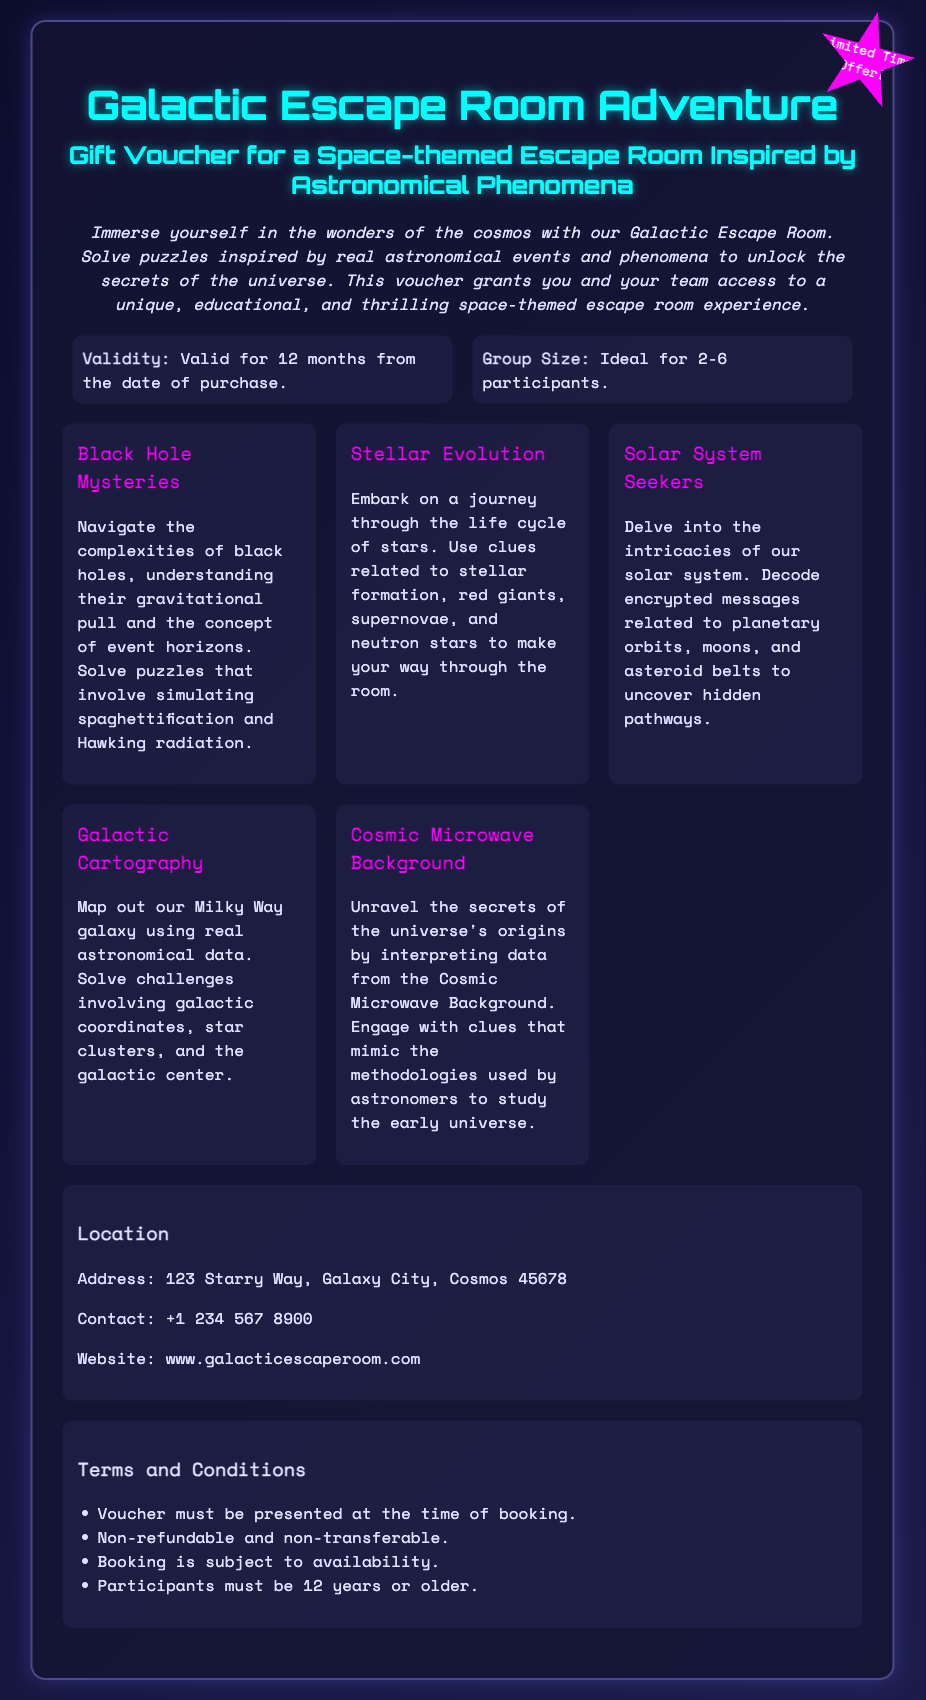What is the validity period of the voucher? The document states that the voucher is valid for 12 months from the date of purchase.
Answer: 12 months What is the ideal group size for the escape room? According to the document, the ideal group size is between 2 to 6 participants.
Answer: 2-6 participants What is one of the features highlighted in the escape room? The document lists multiple features, one of which is "Black Hole Mysteries."
Answer: Black Hole Mysteries What is the address of the location? The voucher specifies the address as 123 Starry Way, Galaxy City, Cosmos 45678.
Answer: 123 Starry Way, Galaxy City, Cosmos 45678 Which celestial phenomenon does one of the clues involve? The document mentions puzzles that involve spaghettification and Hawking radiation related to black holes.
Answer: Black holes What age must participants be to take part? The terms state that participants must be 12 years or older.
Answer: 12 years or older What is the website for the Galactic Escape Room? The document mentions the website as www.galacticescaperoom.com.
Answer: www.galacticescaperoom.com Is the voucher refundable? The terms clarify that the voucher is non-refundable.
Answer: Non-refundable What type of experience does the Galactic Escape Room provide? The document describes the experience as unique, educational, and thrilling.
Answer: Unique, educational, and thrilling 